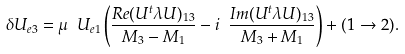<formula> <loc_0><loc_0><loc_500><loc_500>\delta U _ { e 3 } = { \mu } \ U _ { e 1 } \left ( \frac { R e ( U ^ { t } \lambda U ) _ { 1 3 } } { M _ { 3 } - M _ { 1 } } - i \ \frac { I m ( U ^ { t } \lambda U ) _ { 1 3 } } { M _ { 3 } + M _ { 1 } } \right ) + ( 1 \to 2 ) .</formula> 